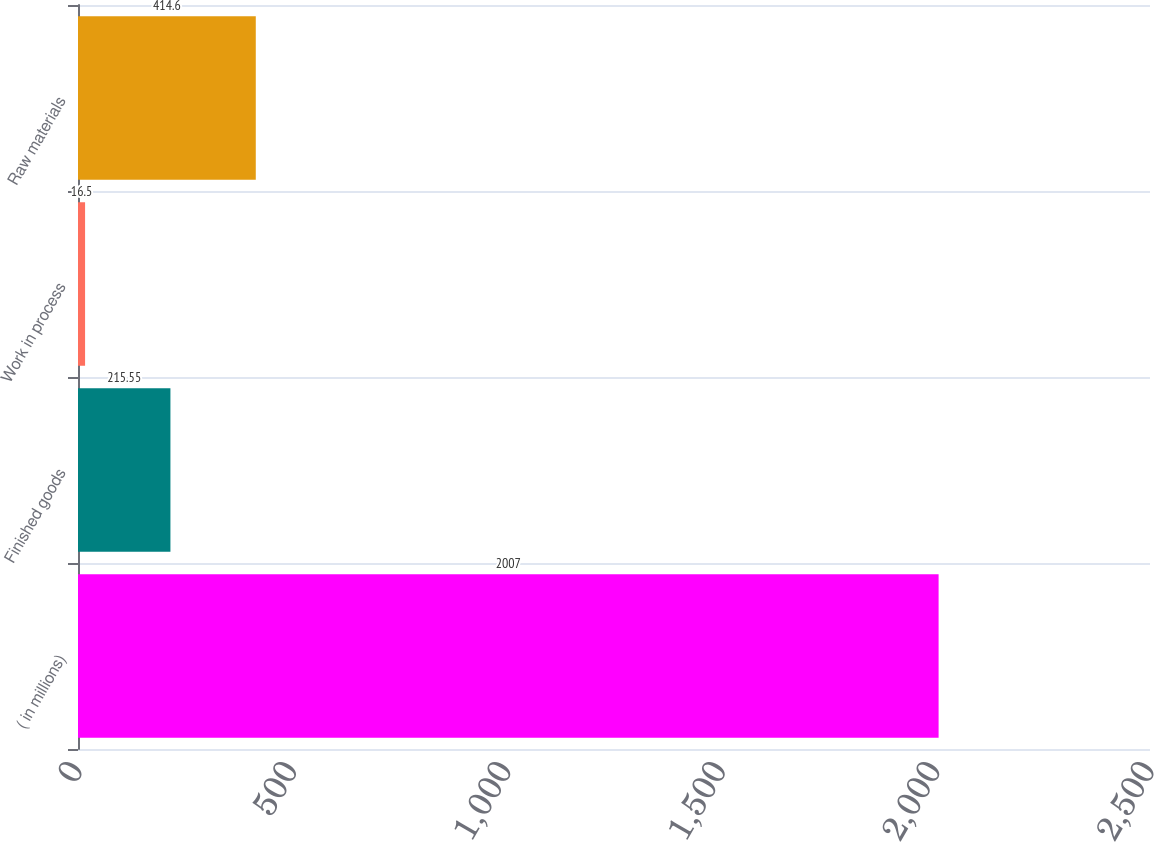Convert chart. <chart><loc_0><loc_0><loc_500><loc_500><bar_chart><fcel>( in millions)<fcel>Finished goods<fcel>Work in process<fcel>Raw materials<nl><fcel>2007<fcel>215.55<fcel>16.5<fcel>414.6<nl></chart> 